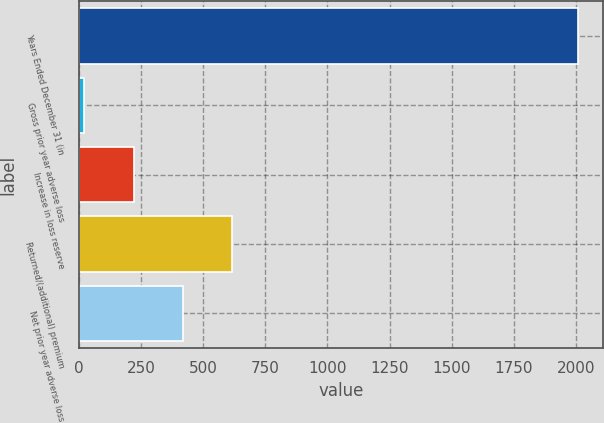Convert chart to OTSL. <chart><loc_0><loc_0><loc_500><loc_500><bar_chart><fcel>Years Ended December 31 (in<fcel>Gross prior year adverse loss<fcel>Increase in loss reserve<fcel>Returned/(additional) premium<fcel>Net prior year adverse loss<nl><fcel>2008<fcel>23<fcel>221.5<fcel>618.5<fcel>420<nl></chart> 